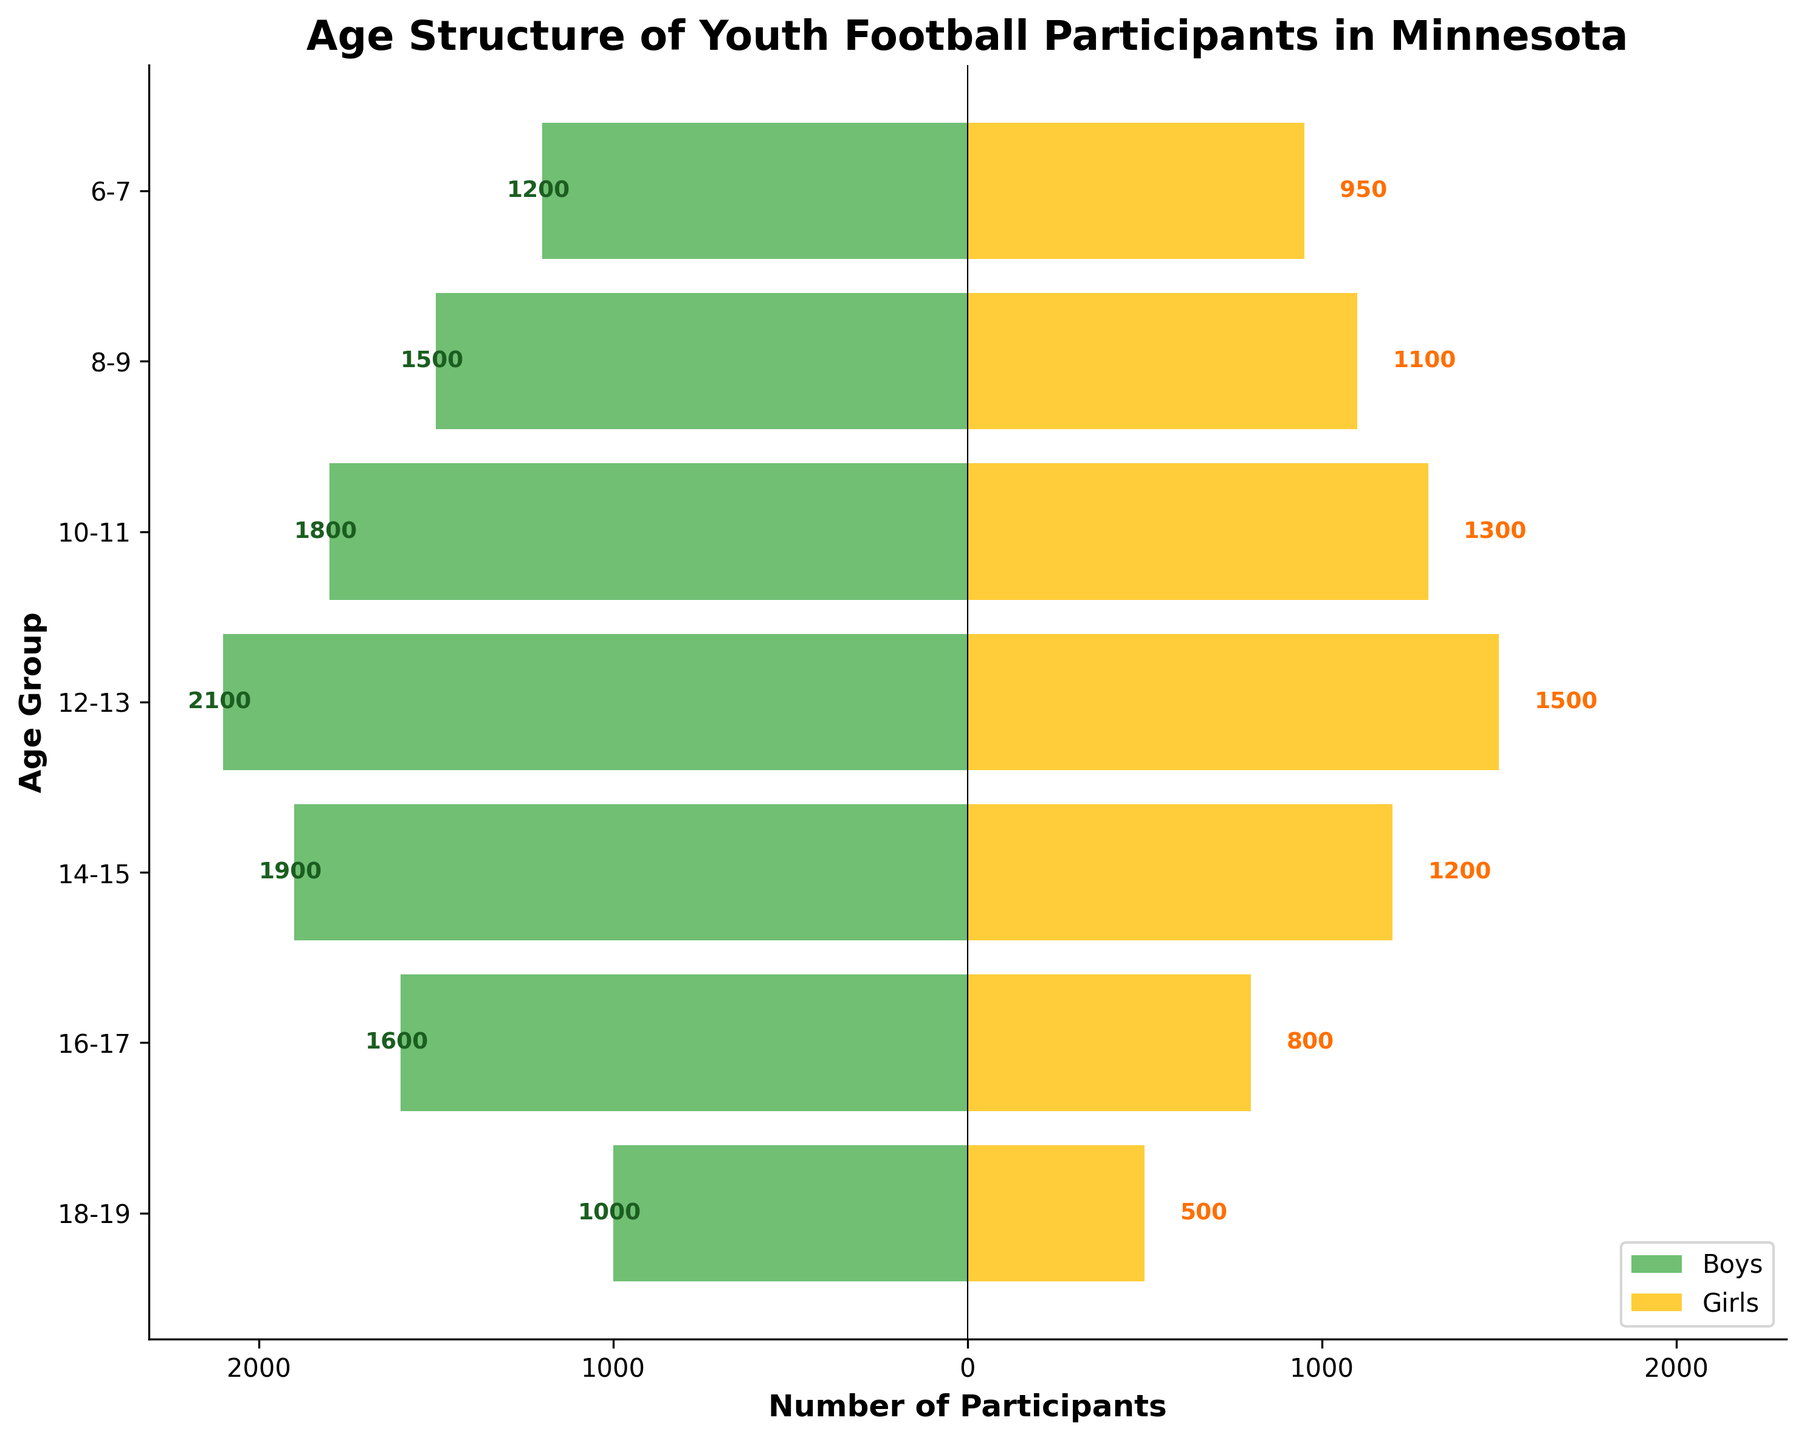What's the title of the figure? The title is displayed at the top of the figure. It reads "Age Structure of Youth Football Participants in Minnesota".
Answer: Age Structure of Youth Football Participants in Minnesota What age group has the highest number of male participants? Look at the horizontal bars representing the male participants for each age group. The 12-13 age group has the longest bar extending to the left.
Answer: 12-13 How many female participants are in the 14-15 age group? Locate the bar representing the 14-15 age group on the right side for female participants. The value at the end of the bar is 1200.
Answer: 1200 Which gender has more participants in the 8-9 age group? Compare the lengths of the bars for the 8-9 age group. The male bar extends further left compared to the female bar extending right.
Answer: Male What is the total number of participants aged 18-19? Add the number of male and female participants in the 18-19 age group: 1000 (male) + 500 (female) = 1500.
Answer: 1500 How does the number of male participants change as age increases from 6-7 to 18-19? Observe the lengths of the male bars from 6-7 through 18-19. The number of male participants increases every 2-year interval up to 12-13, then decreases after that.
Answer: Increases up to 12-13, then decreases What age group sees the largest difference between male and female participants? Calculate the difference between male and female participants for each age group and find the largest difference. The 16-17 age group: 1600 (male) - 800 (female) = 800.
Answer: 16-17 For the 10-11 age group, how many more male participants are there than female participants? Subtract the number of female participants in the 10-11 age group from the number of male participants: 1800 (male) - 1300 (female) = 500.
Answer: 500 Which age group has an equal number of male and female participants? Scan the bars for each age group to see where the lengths for male and female bars are equal. None of the age groups have equal numbers of male and female participants.
Answer: None 